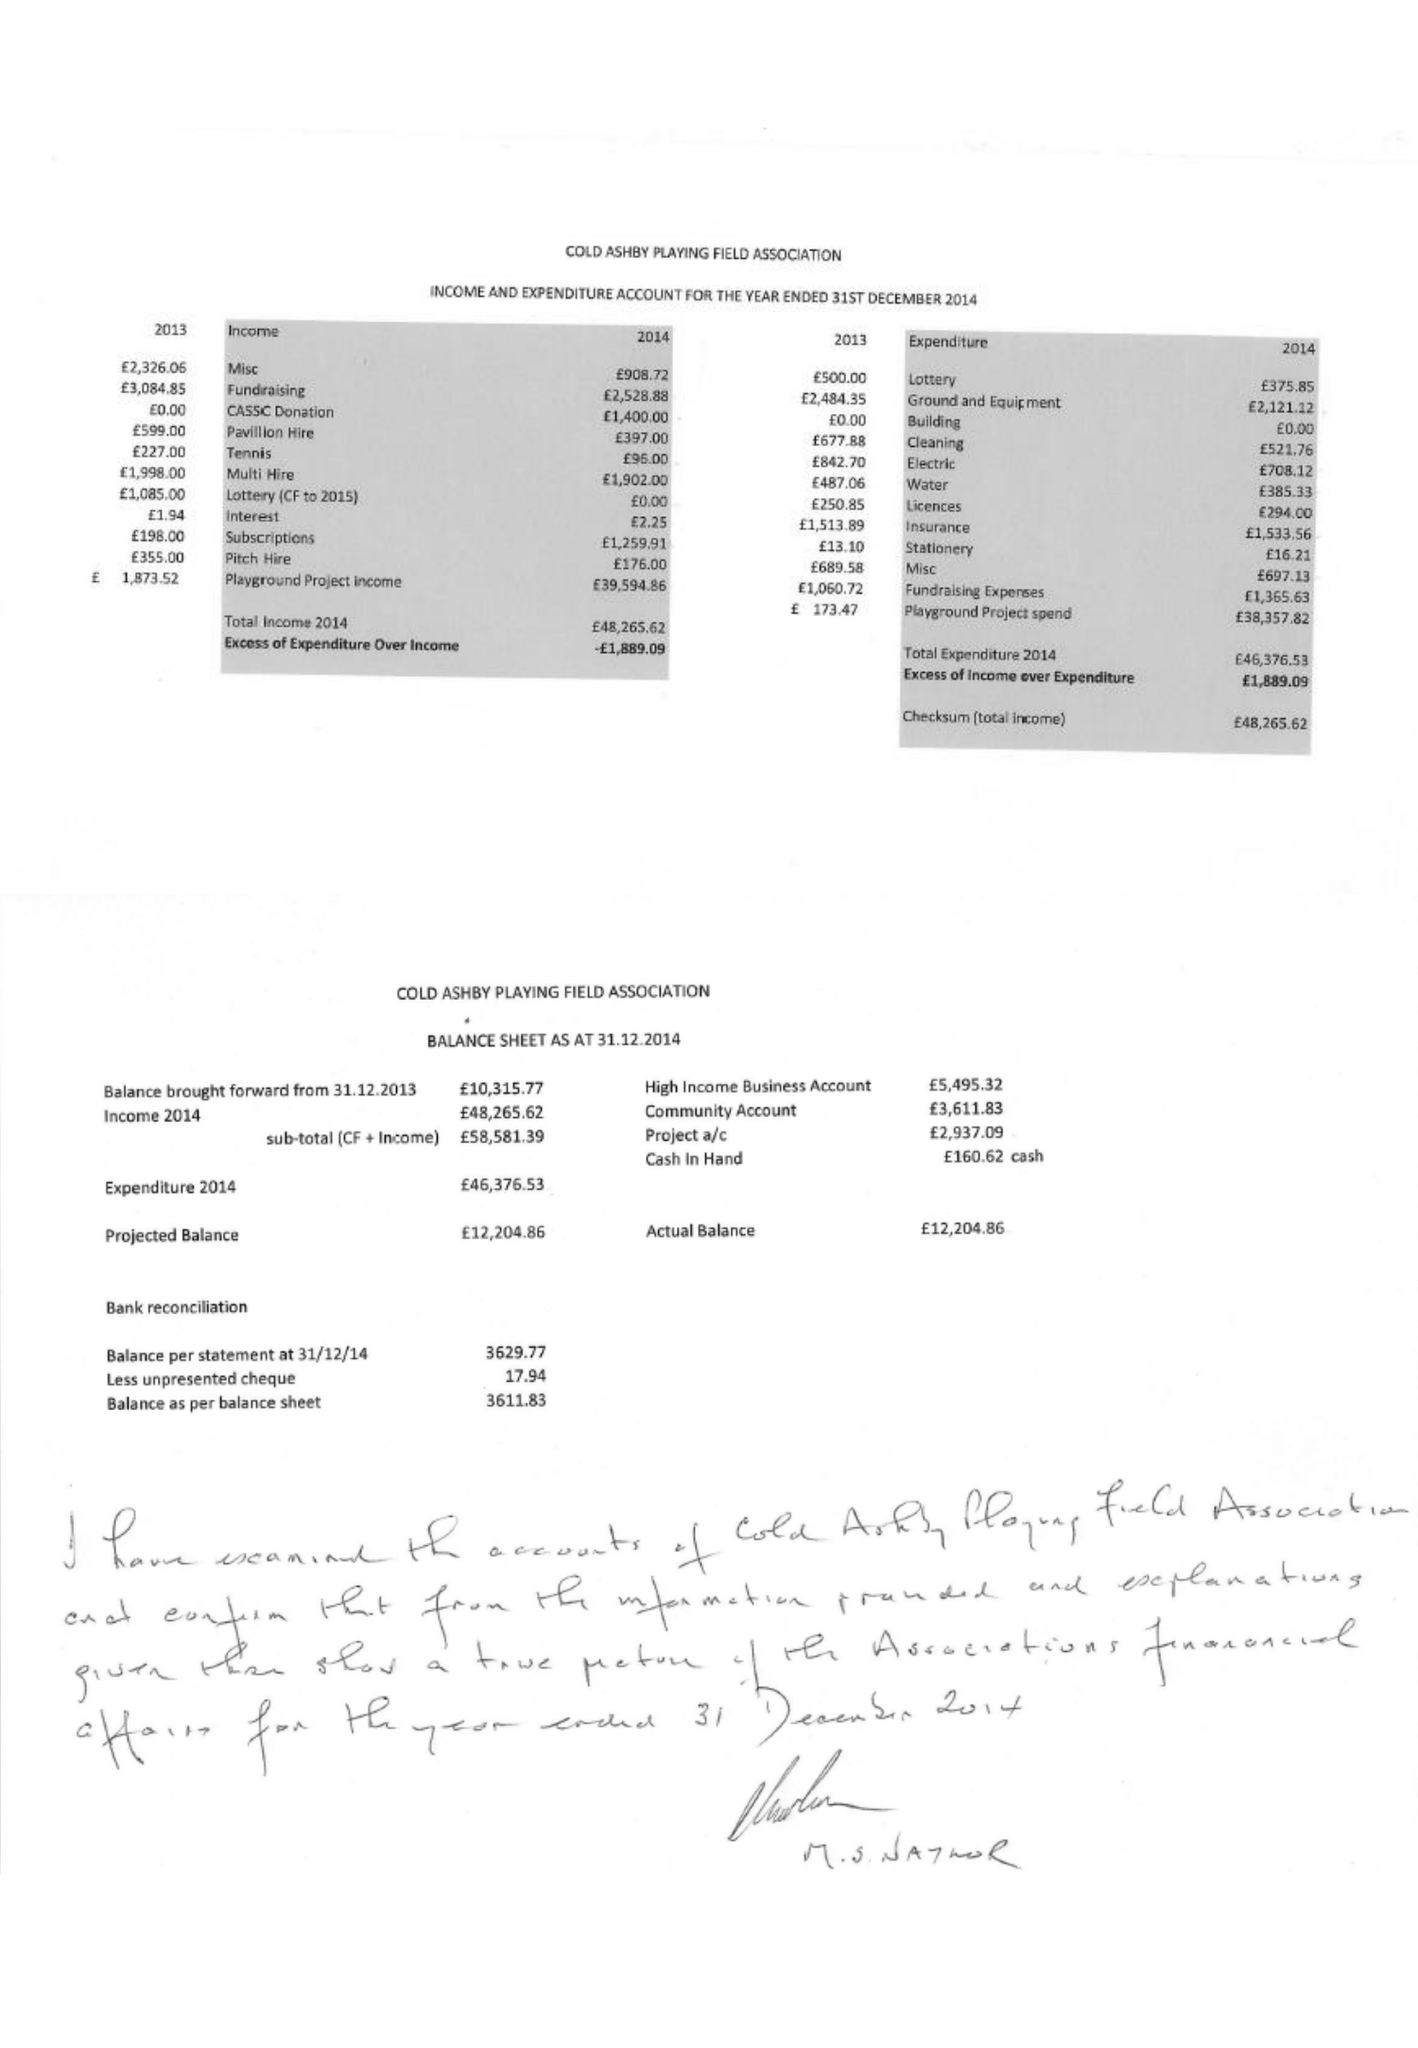What is the value for the address__postcode?
Answer the question using a single word or phrase. NN6 6EF 